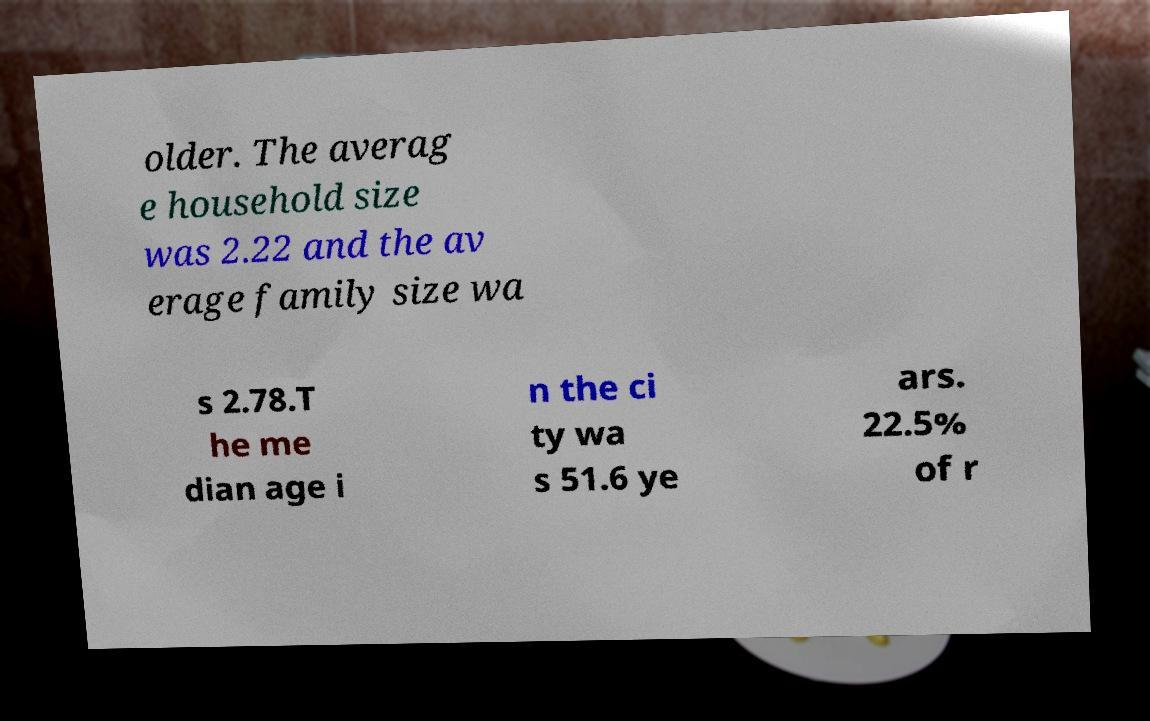Please identify and transcribe the text found in this image. older. The averag e household size was 2.22 and the av erage family size wa s 2.78.T he me dian age i n the ci ty wa s 51.6 ye ars. 22.5% of r 